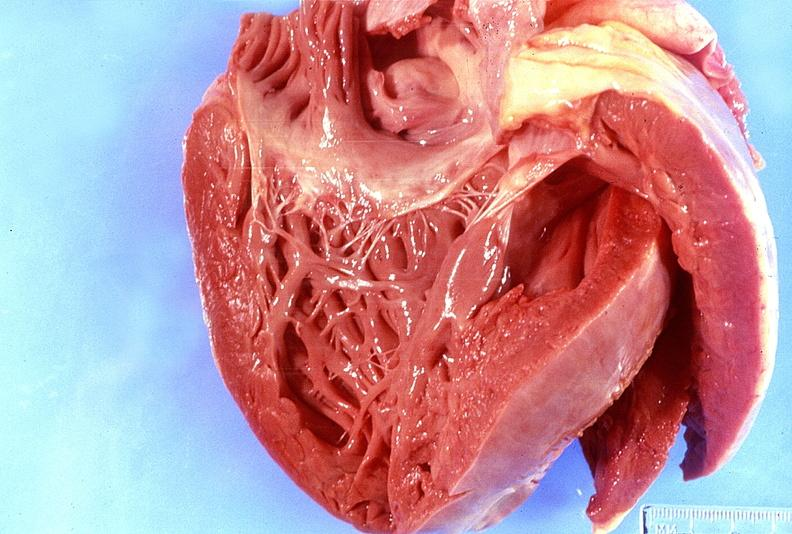does myocardium show normal tricuspid valve?
Answer the question using a single word or phrase. No 